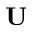<formula> <loc_0><loc_0><loc_500><loc_500>{ U }</formula> 